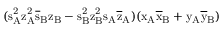Convert formula to latex. <formula><loc_0><loc_0><loc_500><loc_500>( s _ { A } ^ { 2 } \mathrm { z _ { A } ^ { 2 } \mathrm { \overline { s } _ { B } \mathrm { z _ { B } - \mathrm { s _ { B } ^ { 2 } \mathrm { z _ { B } ^ { 2 } \mathrm { s _ { A } \mathrm { \overline { z } _ { A } ) ( \mathrm { x _ { A } \mathrm { \overline { x } _ { B } + \mathrm { y _ { A } \mathrm { \overline { y } _ { B } ) } } } } } } } } } } }</formula> 